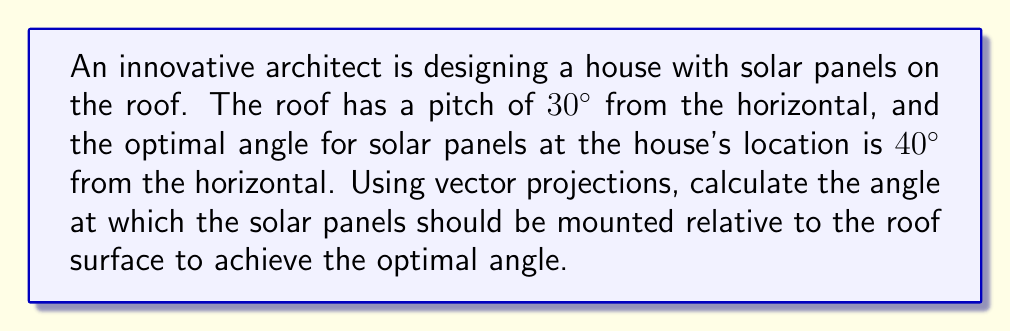Teach me how to tackle this problem. Let's approach this step-by-step using vector projections:

1) First, let's define our vectors:
   - Let $\vec{r}$ be the unit vector along the roof surface
   - Let $\vec{s}$ be the unit vector along the optimal solar panel direction
   - Let $\vec{h}$ be the unit vector along the horizontal

2) We can express these vectors in terms of angles from the horizontal:
   $$\vec{r} = (\cos 30°, \sin 30°)$$
   $$\vec{s} = (\cos 40°, \sin 40°)$$
   $$\vec{h} = (1, 0)$$

3) The angle $\theta$ we're looking for is the angle between $\vec{r}$ and $\vec{s}$. We can find this using the dot product formula:

   $$\cos \theta = \frac{\vec{r} \cdot \vec{s}}{|\vec{r}||\vec{s}|}$$

4) Since these are unit vectors, $|\vec{r}| = |\vec{s}| = 1$, so:

   $$\cos \theta = \vec{r} \cdot \vec{s} = (\cos 30°)(\cos 40°) + (\sin 30°)(\sin 40°)$$

5) Let's calculate this:
   $$\cos \theta = (\frac{\sqrt{3}}{2})(0.7660) + (0.5)(0.6428) = 0.9397$$

6) To get $\theta$, we take the inverse cosine (arccos):

   $$\theta = \arccos(0.9397) \approx 20.0°$$

Therefore, the solar panels should be mounted at an angle of approximately 20.0° relative to the roof surface.
Answer: $20.0°$ 